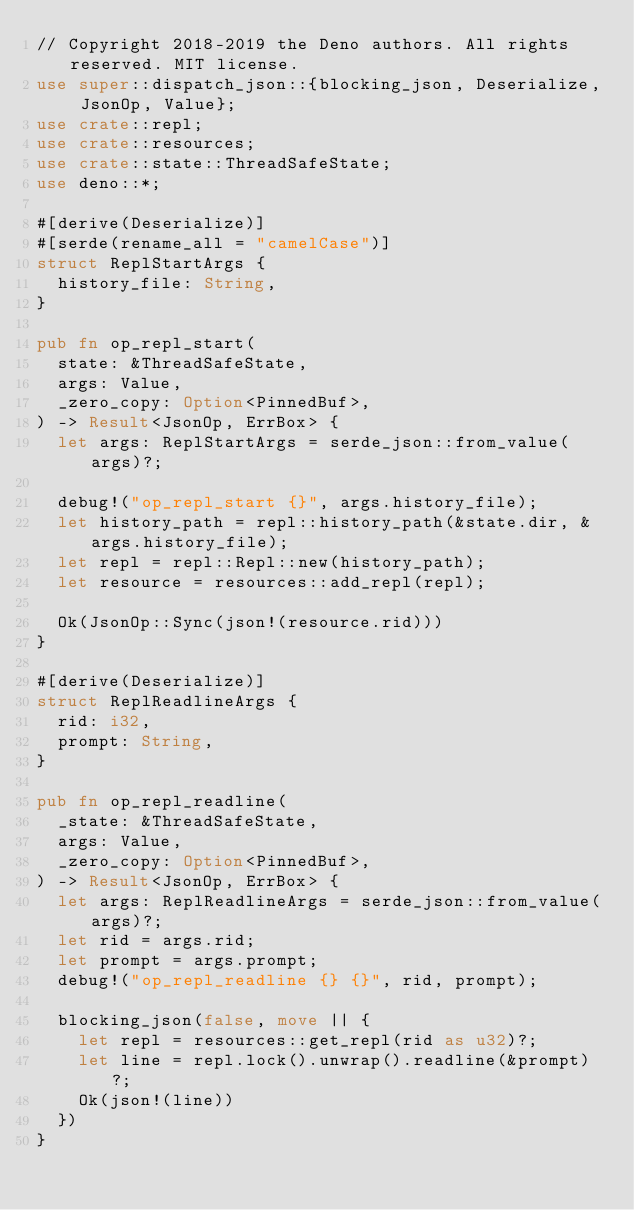Convert code to text. <code><loc_0><loc_0><loc_500><loc_500><_Rust_>// Copyright 2018-2019 the Deno authors. All rights reserved. MIT license.
use super::dispatch_json::{blocking_json, Deserialize, JsonOp, Value};
use crate::repl;
use crate::resources;
use crate::state::ThreadSafeState;
use deno::*;

#[derive(Deserialize)]
#[serde(rename_all = "camelCase")]
struct ReplStartArgs {
  history_file: String,
}

pub fn op_repl_start(
  state: &ThreadSafeState,
  args: Value,
  _zero_copy: Option<PinnedBuf>,
) -> Result<JsonOp, ErrBox> {
  let args: ReplStartArgs = serde_json::from_value(args)?;

  debug!("op_repl_start {}", args.history_file);
  let history_path = repl::history_path(&state.dir, &args.history_file);
  let repl = repl::Repl::new(history_path);
  let resource = resources::add_repl(repl);

  Ok(JsonOp::Sync(json!(resource.rid)))
}

#[derive(Deserialize)]
struct ReplReadlineArgs {
  rid: i32,
  prompt: String,
}

pub fn op_repl_readline(
  _state: &ThreadSafeState,
  args: Value,
  _zero_copy: Option<PinnedBuf>,
) -> Result<JsonOp, ErrBox> {
  let args: ReplReadlineArgs = serde_json::from_value(args)?;
  let rid = args.rid;
  let prompt = args.prompt;
  debug!("op_repl_readline {} {}", rid, prompt);

  blocking_json(false, move || {
    let repl = resources::get_repl(rid as u32)?;
    let line = repl.lock().unwrap().readline(&prompt)?;
    Ok(json!(line))
  })
}
</code> 